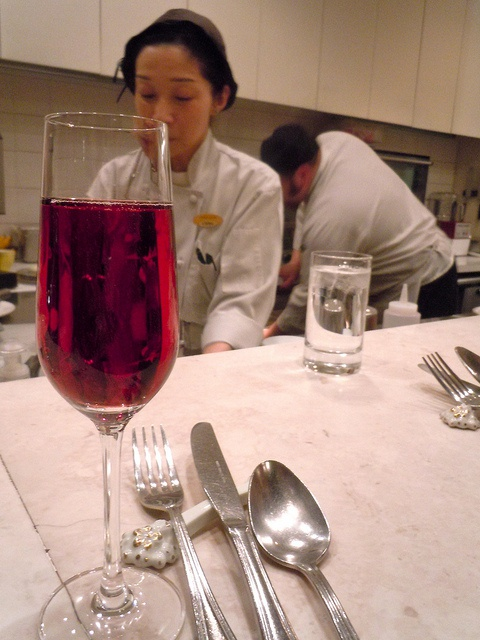Describe the objects in this image and their specific colors. I can see wine glass in darkgray, maroon, black, gray, and tan tones, people in darkgray, gray, and brown tones, people in darkgray, tan, black, and gray tones, spoon in darkgray, gray, and white tones, and cup in darkgray, lightgray, gray, and tan tones in this image. 